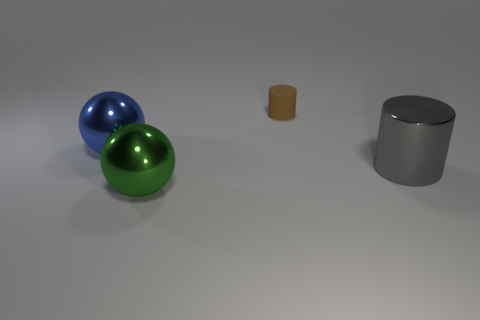Add 2 small green metal cylinders. How many objects exist? 6 Subtract all tiny brown rubber things. Subtract all large gray cylinders. How many objects are left? 2 Add 2 tiny matte things. How many tiny matte things are left? 3 Add 4 green rubber cylinders. How many green rubber cylinders exist? 4 Subtract 0 blue blocks. How many objects are left? 4 Subtract 2 spheres. How many spheres are left? 0 Subtract all green cylinders. Subtract all purple cubes. How many cylinders are left? 2 Subtract all brown cylinders. How many blue balls are left? 1 